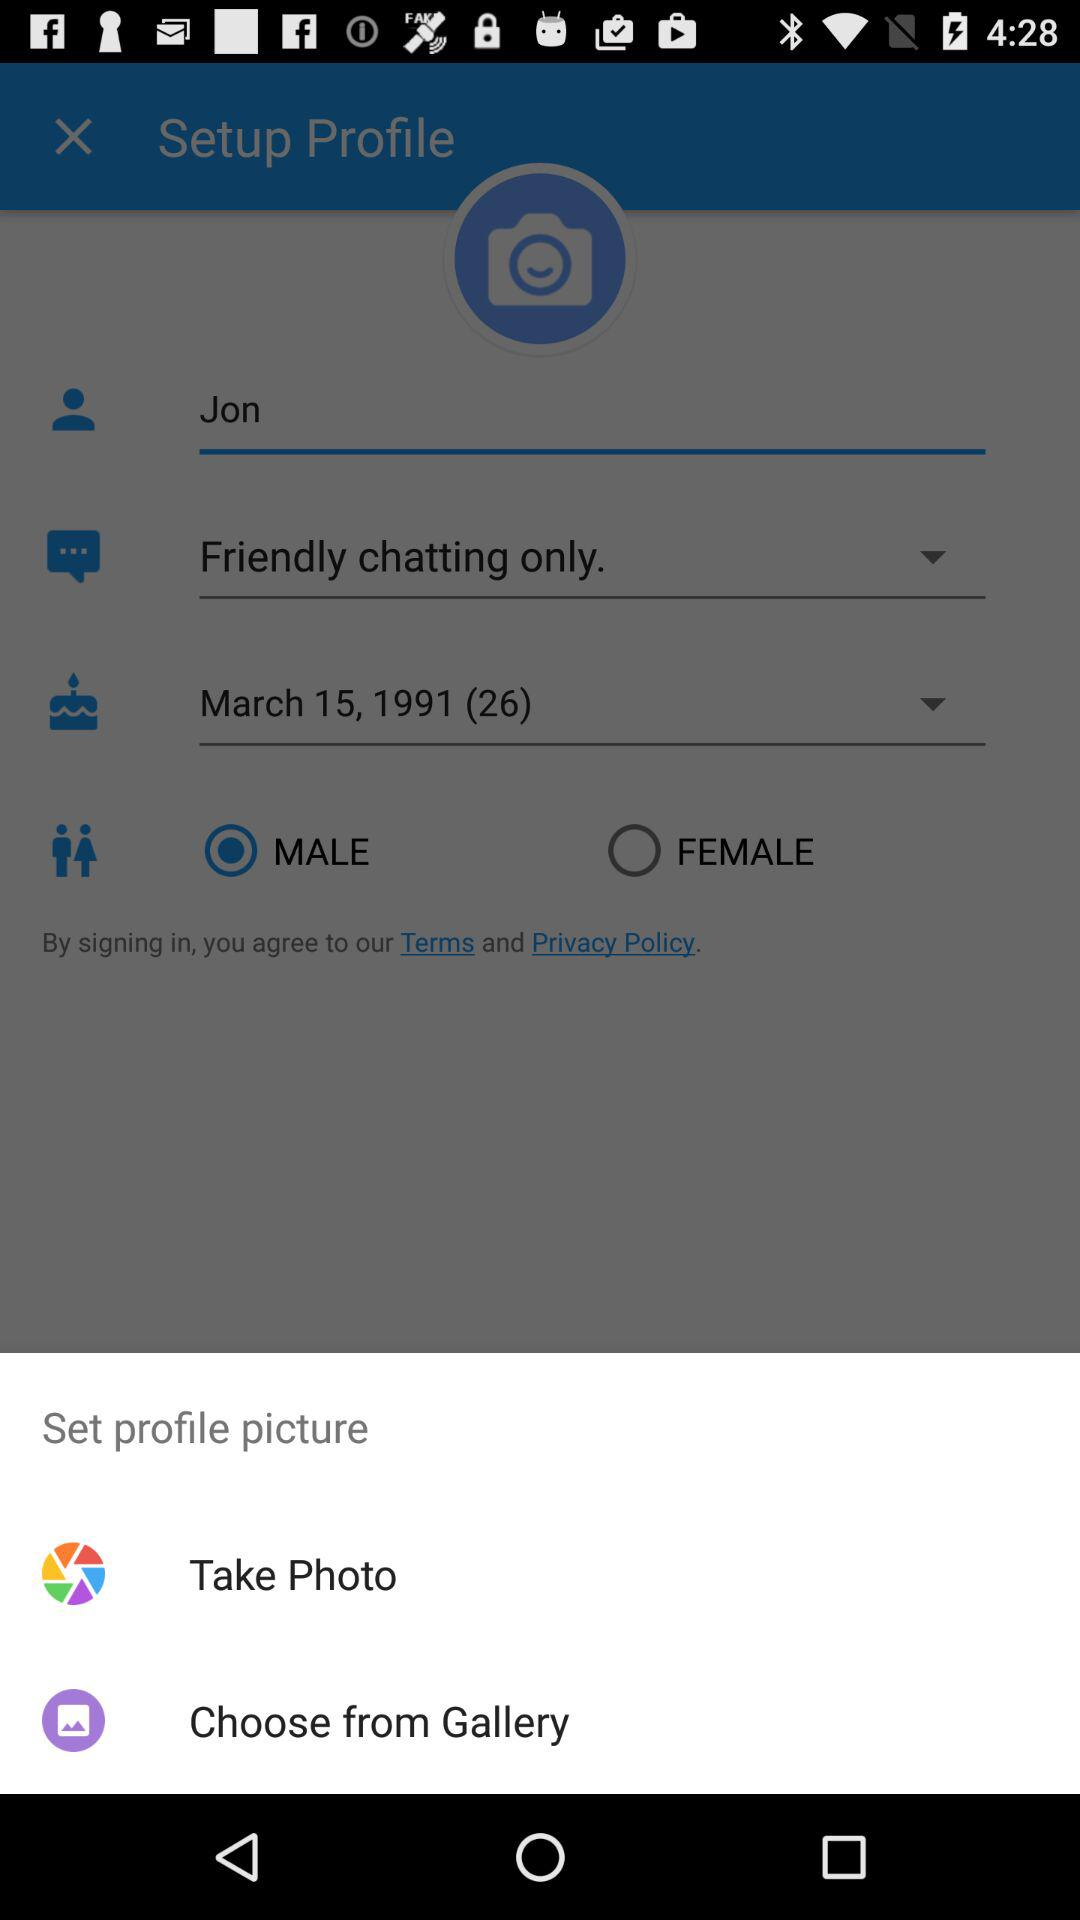How many profile pictures are available to choose from?
Answer the question using a single word or phrase. 2 